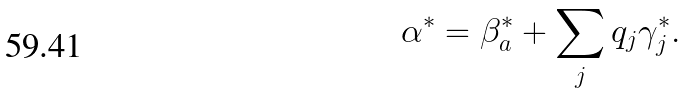Convert formula to latex. <formula><loc_0><loc_0><loc_500><loc_500>\alpha ^ { * } = \beta _ { a } ^ { * } + \sum _ { j } q _ { j } \gamma _ { j } ^ { * } .</formula> 